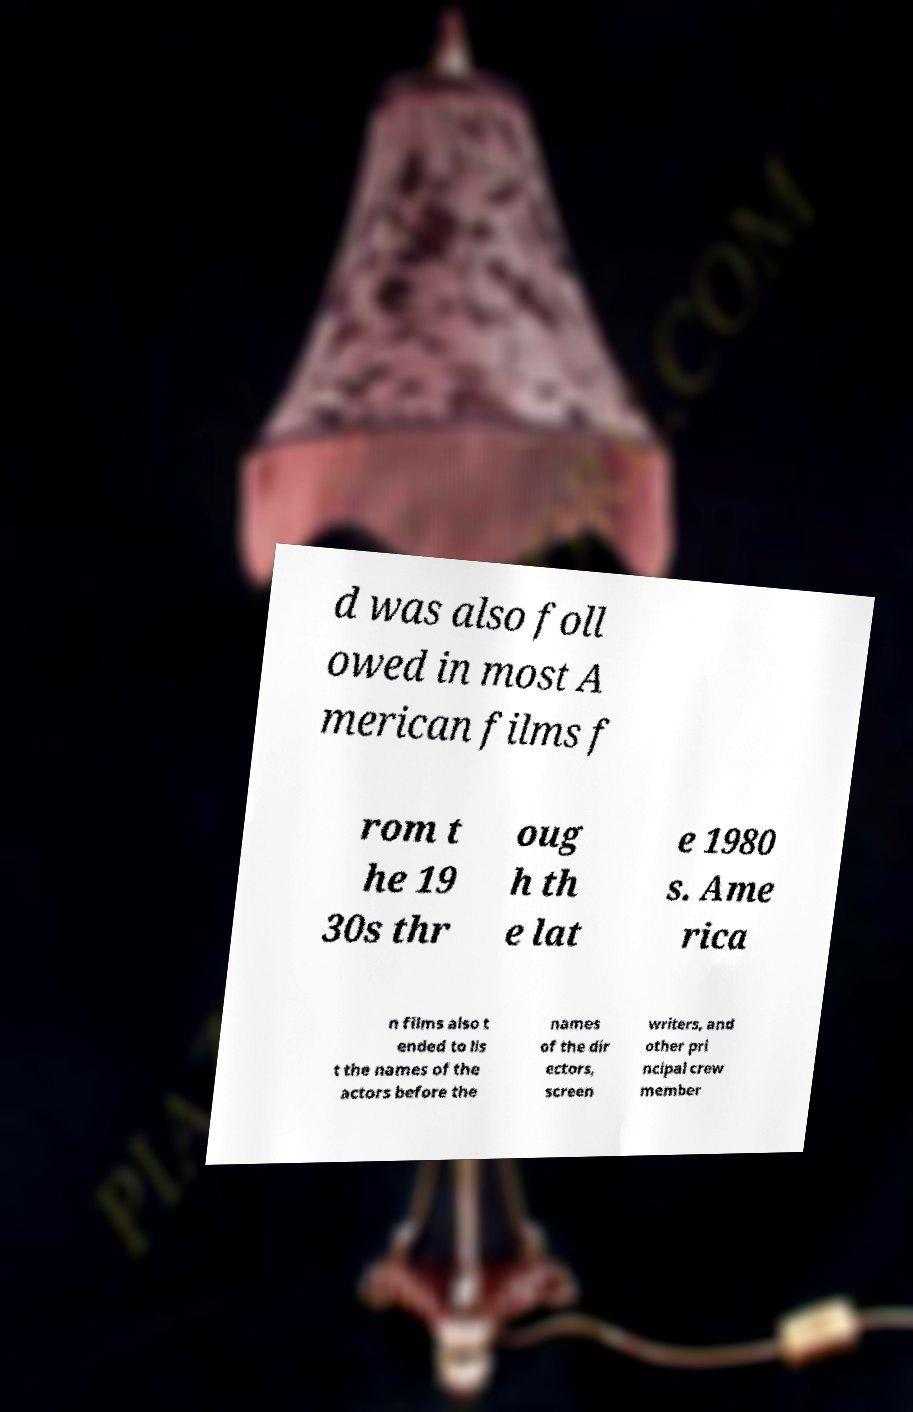What messages or text are displayed in this image? I need them in a readable, typed format. d was also foll owed in most A merican films f rom t he 19 30s thr oug h th e lat e 1980 s. Ame rica n films also t ended to lis t the names of the actors before the names of the dir ectors, screen writers, and other pri ncipal crew member 